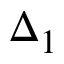<formula> <loc_0><loc_0><loc_500><loc_500>\Delta _ { 1 }</formula> 